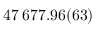Convert formula to latex. <formula><loc_0><loc_0><loc_500><loc_500>4 7 \, 6 7 7 . 9 6 ( 6 3 )</formula> 